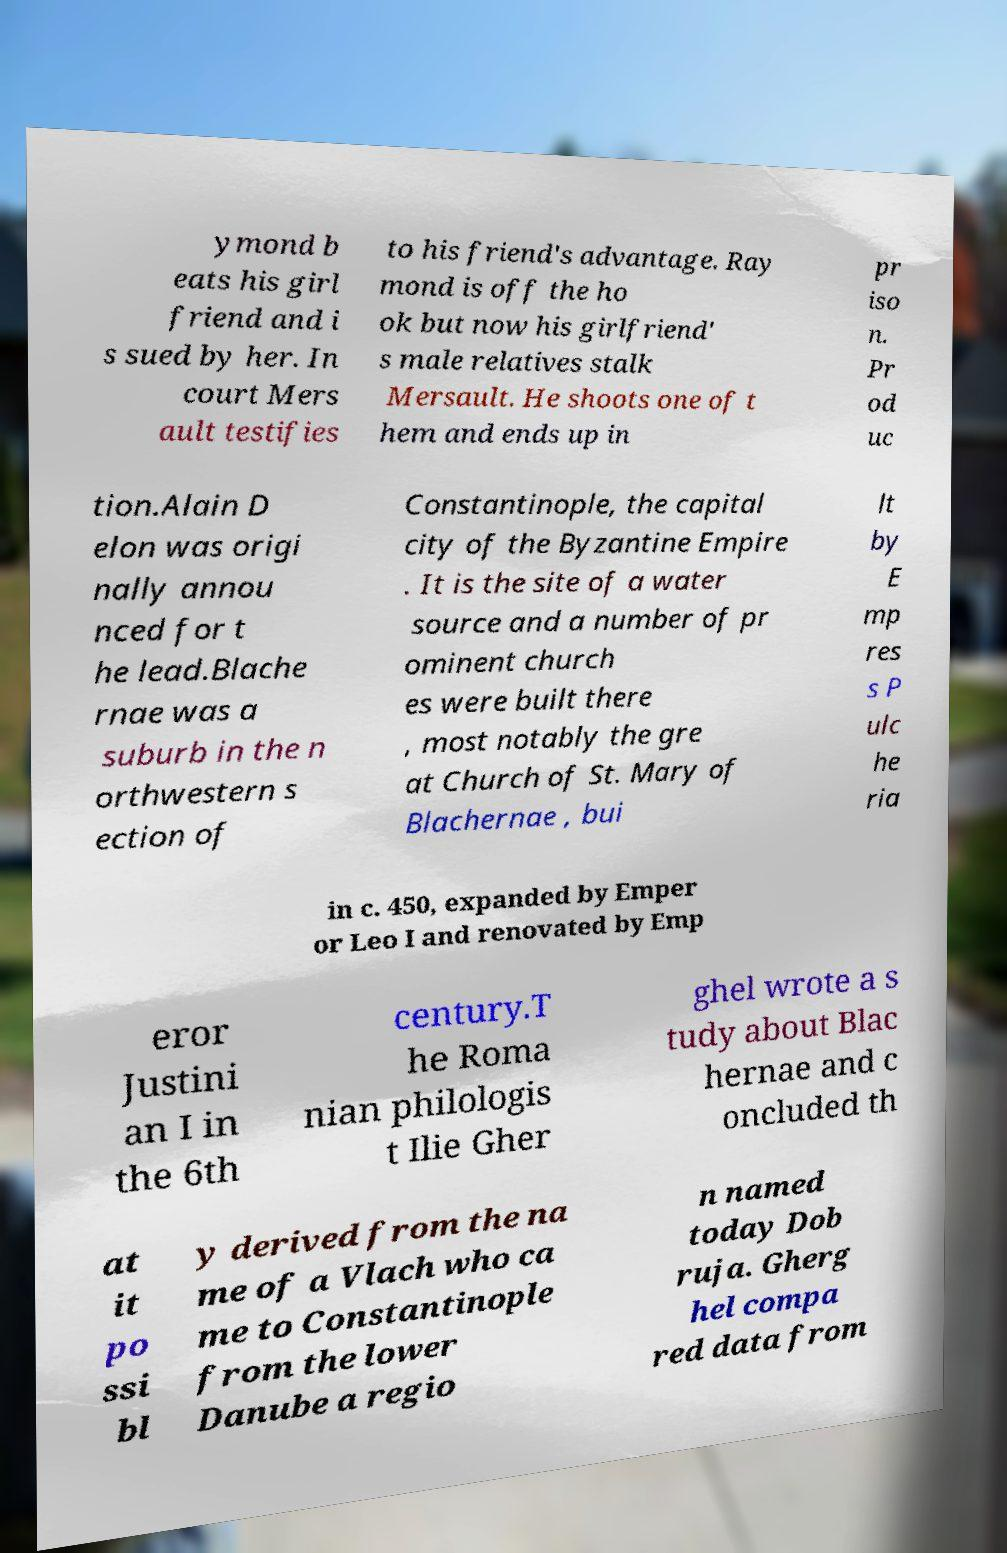Please identify and transcribe the text found in this image. ymond b eats his girl friend and i s sued by her. In court Mers ault testifies to his friend's advantage. Ray mond is off the ho ok but now his girlfriend' s male relatives stalk Mersault. He shoots one of t hem and ends up in pr iso n. Pr od uc tion.Alain D elon was origi nally annou nced for t he lead.Blache rnae was a suburb in the n orthwestern s ection of Constantinople, the capital city of the Byzantine Empire . It is the site of a water source and a number of pr ominent church es were built there , most notably the gre at Church of St. Mary of Blachernae , bui lt by E mp res s P ulc he ria in c. 450, expanded by Emper or Leo I and renovated by Emp eror Justini an I in the 6th century.T he Roma nian philologis t Ilie Gher ghel wrote a s tudy about Blac hernae and c oncluded th at it po ssi bl y derived from the na me of a Vlach who ca me to Constantinople from the lower Danube a regio n named today Dob ruja. Gherg hel compa red data from 